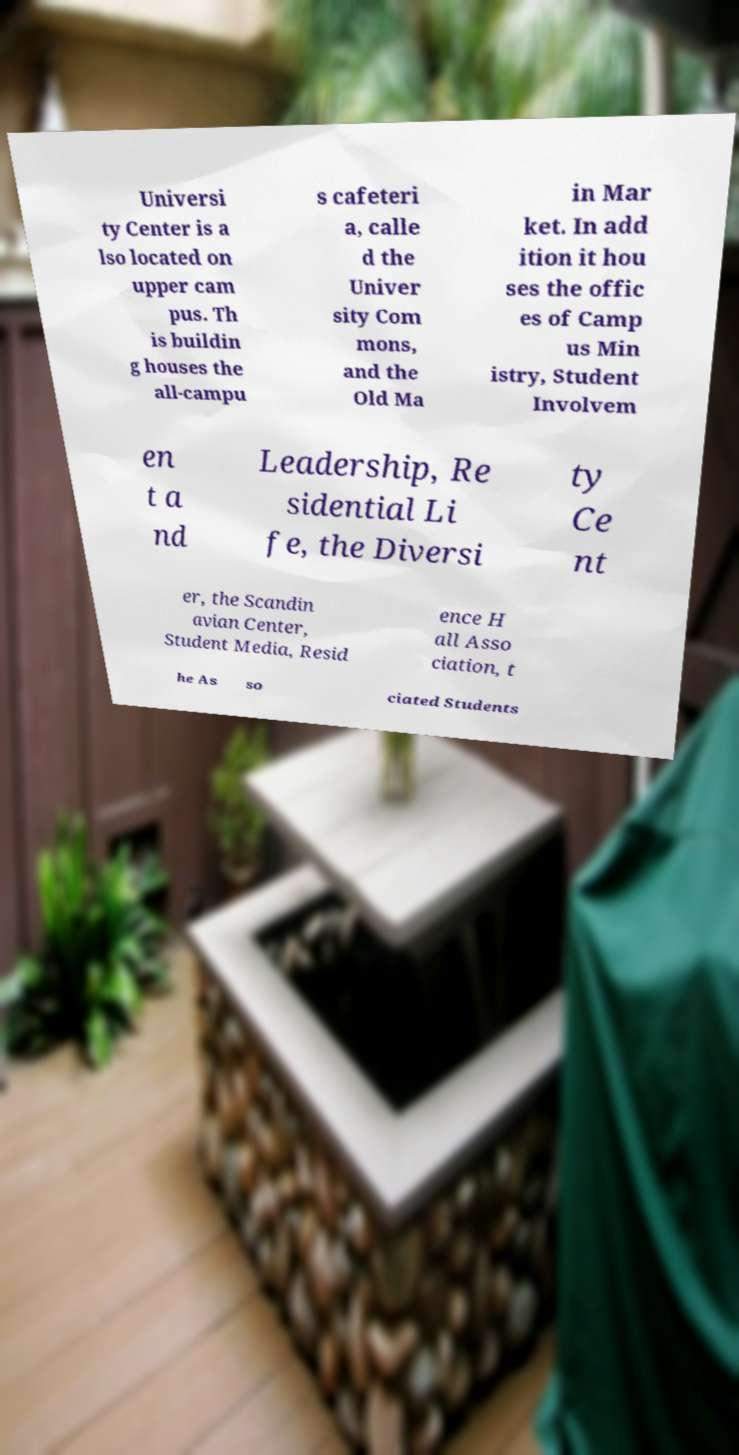Please identify and transcribe the text found in this image. Universi ty Center is a lso located on upper cam pus. Th is buildin g houses the all-campu s cafeteri a, calle d the Univer sity Com mons, and the Old Ma in Mar ket. In add ition it hou ses the offic es of Camp us Min istry, Student Involvem en t a nd Leadership, Re sidential Li fe, the Diversi ty Ce nt er, the Scandin avian Center, Student Media, Resid ence H all Asso ciation, t he As so ciated Students 